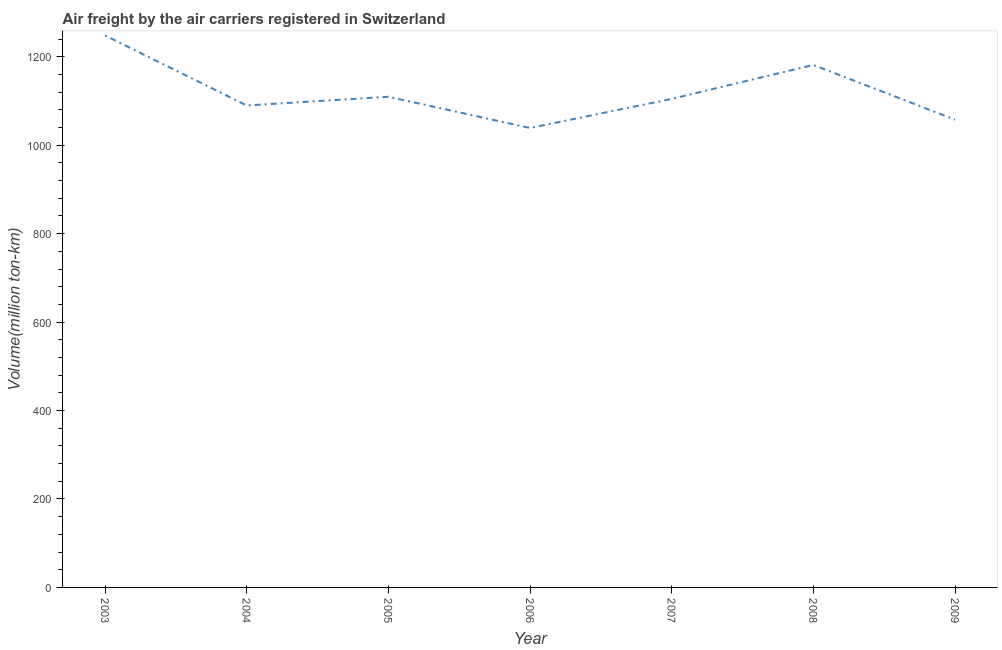What is the air freight in 2005?
Provide a succinct answer. 1109.64. Across all years, what is the maximum air freight?
Offer a very short reply. 1248.3. Across all years, what is the minimum air freight?
Give a very brief answer. 1039.03. In which year was the air freight maximum?
Your response must be concise. 2003. In which year was the air freight minimum?
Provide a short and direct response. 2006. What is the sum of the air freight?
Provide a succinct answer. 7831.21. What is the difference between the air freight in 2003 and 2009?
Make the answer very short. 190.41. What is the average air freight per year?
Provide a short and direct response. 1118.74. What is the median air freight?
Keep it short and to the point. 1104.84. What is the ratio of the air freight in 2003 to that in 2008?
Offer a terse response. 1.06. Is the air freight in 2003 less than that in 2005?
Make the answer very short. No. What is the difference between the highest and the second highest air freight?
Offer a terse response. 66.73. Is the sum of the air freight in 2003 and 2006 greater than the maximum air freight across all years?
Offer a very short reply. Yes. What is the difference between the highest and the lowest air freight?
Your answer should be very brief. 209.27. In how many years, is the air freight greater than the average air freight taken over all years?
Your answer should be very brief. 2. How many lines are there?
Make the answer very short. 1. What is the difference between two consecutive major ticks on the Y-axis?
Provide a succinct answer. 200. Are the values on the major ticks of Y-axis written in scientific E-notation?
Offer a very short reply. No. Does the graph contain grids?
Provide a succinct answer. No. What is the title of the graph?
Provide a succinct answer. Air freight by the air carriers registered in Switzerland. What is the label or title of the X-axis?
Provide a succinct answer. Year. What is the label or title of the Y-axis?
Give a very brief answer. Volume(million ton-km). What is the Volume(million ton-km) of 2003?
Keep it short and to the point. 1248.3. What is the Volume(million ton-km) in 2004?
Your answer should be very brief. 1089.93. What is the Volume(million ton-km) of 2005?
Your response must be concise. 1109.64. What is the Volume(million ton-km) of 2006?
Provide a succinct answer. 1039.03. What is the Volume(million ton-km) of 2007?
Give a very brief answer. 1104.84. What is the Volume(million ton-km) of 2008?
Your answer should be compact. 1181.57. What is the Volume(million ton-km) in 2009?
Ensure brevity in your answer.  1057.89. What is the difference between the Volume(million ton-km) in 2003 and 2004?
Your response must be concise. 158.37. What is the difference between the Volume(million ton-km) in 2003 and 2005?
Offer a very short reply. 138.66. What is the difference between the Volume(million ton-km) in 2003 and 2006?
Offer a terse response. 209.28. What is the difference between the Volume(million ton-km) in 2003 and 2007?
Keep it short and to the point. 143.46. What is the difference between the Volume(million ton-km) in 2003 and 2008?
Ensure brevity in your answer.  66.73. What is the difference between the Volume(million ton-km) in 2003 and 2009?
Make the answer very short. 190.41. What is the difference between the Volume(million ton-km) in 2004 and 2005?
Make the answer very short. -19.71. What is the difference between the Volume(million ton-km) in 2004 and 2006?
Your answer should be compact. 50.91. What is the difference between the Volume(million ton-km) in 2004 and 2007?
Provide a short and direct response. -14.91. What is the difference between the Volume(million ton-km) in 2004 and 2008?
Ensure brevity in your answer.  -91.63. What is the difference between the Volume(million ton-km) in 2004 and 2009?
Your answer should be very brief. 32.04. What is the difference between the Volume(million ton-km) in 2005 and 2006?
Offer a terse response. 70.61. What is the difference between the Volume(million ton-km) in 2005 and 2007?
Give a very brief answer. 4.8. What is the difference between the Volume(million ton-km) in 2005 and 2008?
Offer a terse response. -71.93. What is the difference between the Volume(million ton-km) in 2005 and 2009?
Make the answer very short. 51.75. What is the difference between the Volume(million ton-km) in 2006 and 2007?
Give a very brief answer. -65.82. What is the difference between the Volume(million ton-km) in 2006 and 2008?
Give a very brief answer. -142.54. What is the difference between the Volume(million ton-km) in 2006 and 2009?
Make the answer very short. -18.87. What is the difference between the Volume(million ton-km) in 2007 and 2008?
Keep it short and to the point. -76.72. What is the difference between the Volume(million ton-km) in 2007 and 2009?
Keep it short and to the point. 46.95. What is the difference between the Volume(million ton-km) in 2008 and 2009?
Provide a short and direct response. 123.67. What is the ratio of the Volume(million ton-km) in 2003 to that in 2004?
Your response must be concise. 1.15. What is the ratio of the Volume(million ton-km) in 2003 to that in 2005?
Ensure brevity in your answer.  1.12. What is the ratio of the Volume(million ton-km) in 2003 to that in 2006?
Your answer should be very brief. 1.2. What is the ratio of the Volume(million ton-km) in 2003 to that in 2007?
Offer a terse response. 1.13. What is the ratio of the Volume(million ton-km) in 2003 to that in 2008?
Offer a terse response. 1.06. What is the ratio of the Volume(million ton-km) in 2003 to that in 2009?
Keep it short and to the point. 1.18. What is the ratio of the Volume(million ton-km) in 2004 to that in 2005?
Offer a very short reply. 0.98. What is the ratio of the Volume(million ton-km) in 2004 to that in 2006?
Provide a succinct answer. 1.05. What is the ratio of the Volume(million ton-km) in 2004 to that in 2007?
Ensure brevity in your answer.  0.99. What is the ratio of the Volume(million ton-km) in 2004 to that in 2008?
Provide a succinct answer. 0.92. What is the ratio of the Volume(million ton-km) in 2004 to that in 2009?
Your answer should be compact. 1.03. What is the ratio of the Volume(million ton-km) in 2005 to that in 2006?
Your answer should be compact. 1.07. What is the ratio of the Volume(million ton-km) in 2005 to that in 2007?
Provide a short and direct response. 1. What is the ratio of the Volume(million ton-km) in 2005 to that in 2008?
Your answer should be very brief. 0.94. What is the ratio of the Volume(million ton-km) in 2005 to that in 2009?
Your answer should be very brief. 1.05. What is the ratio of the Volume(million ton-km) in 2006 to that in 2008?
Ensure brevity in your answer.  0.88. What is the ratio of the Volume(million ton-km) in 2006 to that in 2009?
Keep it short and to the point. 0.98. What is the ratio of the Volume(million ton-km) in 2007 to that in 2008?
Offer a very short reply. 0.94. What is the ratio of the Volume(million ton-km) in 2007 to that in 2009?
Ensure brevity in your answer.  1.04. What is the ratio of the Volume(million ton-km) in 2008 to that in 2009?
Provide a succinct answer. 1.12. 